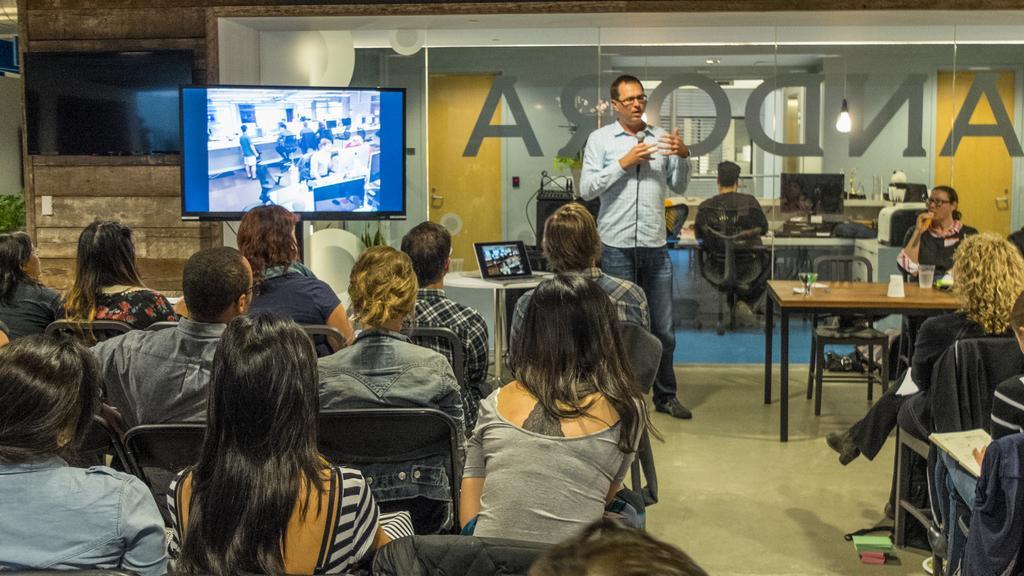Describe this image in one or two sentences. In this image i can see number of people sitting on chairs and a person wearing shirt and jeans standing and holding a microphone. In the background i can see 2 television screens, the wall , a laptop and a glass through which i can see another cabin in which there is a person sitting on a chair. 